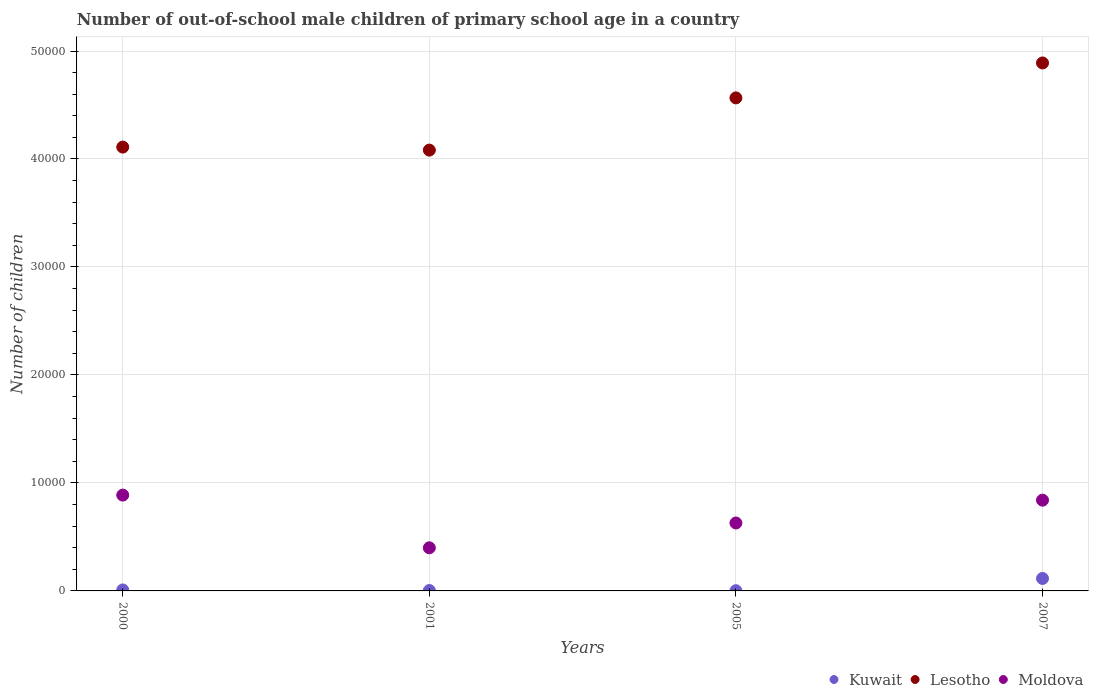How many different coloured dotlines are there?
Offer a very short reply. 3. What is the number of out-of-school male children in Kuwait in 2000?
Offer a terse response. 91. Across all years, what is the maximum number of out-of-school male children in Moldova?
Give a very brief answer. 8873. In which year was the number of out-of-school male children in Moldova maximum?
Ensure brevity in your answer.  2000. In which year was the number of out-of-school male children in Kuwait minimum?
Ensure brevity in your answer.  2005. What is the total number of out-of-school male children in Moldova in the graph?
Your answer should be very brief. 2.76e+04. What is the difference between the number of out-of-school male children in Kuwait in 2000 and that in 2007?
Your answer should be compact. -1064. What is the difference between the number of out-of-school male children in Lesotho in 2001 and the number of out-of-school male children in Moldova in 2005?
Ensure brevity in your answer.  3.45e+04. What is the average number of out-of-school male children in Kuwait per year?
Offer a terse response. 325.5. In the year 2007, what is the difference between the number of out-of-school male children in Lesotho and number of out-of-school male children in Moldova?
Ensure brevity in your answer.  4.05e+04. What is the ratio of the number of out-of-school male children in Lesotho in 2000 to that in 2005?
Offer a terse response. 0.9. What is the difference between the highest and the second highest number of out-of-school male children in Moldova?
Provide a succinct answer. 469. What is the difference between the highest and the lowest number of out-of-school male children in Moldova?
Provide a succinct answer. 4880. In how many years, is the number of out-of-school male children in Kuwait greater than the average number of out-of-school male children in Kuwait taken over all years?
Your response must be concise. 1. Is the sum of the number of out-of-school male children in Lesotho in 2000 and 2001 greater than the maximum number of out-of-school male children in Kuwait across all years?
Provide a succinct answer. Yes. Is it the case that in every year, the sum of the number of out-of-school male children in Moldova and number of out-of-school male children in Lesotho  is greater than the number of out-of-school male children in Kuwait?
Offer a terse response. Yes. Does the number of out-of-school male children in Kuwait monotonically increase over the years?
Provide a succinct answer. No. Is the number of out-of-school male children in Kuwait strictly greater than the number of out-of-school male children in Moldova over the years?
Make the answer very short. No. Is the number of out-of-school male children in Moldova strictly less than the number of out-of-school male children in Lesotho over the years?
Give a very brief answer. Yes. How many dotlines are there?
Your answer should be compact. 3. Are the values on the major ticks of Y-axis written in scientific E-notation?
Give a very brief answer. No. Where does the legend appear in the graph?
Your answer should be compact. Bottom right. How are the legend labels stacked?
Your answer should be very brief. Horizontal. What is the title of the graph?
Make the answer very short. Number of out-of-school male children of primary school age in a country. What is the label or title of the X-axis?
Make the answer very short. Years. What is the label or title of the Y-axis?
Provide a short and direct response. Number of children. What is the Number of children of Kuwait in 2000?
Offer a very short reply. 91. What is the Number of children of Lesotho in 2000?
Offer a very short reply. 4.11e+04. What is the Number of children of Moldova in 2000?
Provide a short and direct response. 8873. What is the Number of children in Kuwait in 2001?
Offer a very short reply. 38. What is the Number of children in Lesotho in 2001?
Offer a terse response. 4.08e+04. What is the Number of children in Moldova in 2001?
Your response must be concise. 3993. What is the Number of children in Kuwait in 2005?
Your answer should be very brief. 18. What is the Number of children in Lesotho in 2005?
Your answer should be compact. 4.57e+04. What is the Number of children in Moldova in 2005?
Your response must be concise. 6291. What is the Number of children of Kuwait in 2007?
Make the answer very short. 1155. What is the Number of children in Lesotho in 2007?
Give a very brief answer. 4.89e+04. What is the Number of children in Moldova in 2007?
Keep it short and to the point. 8404. Across all years, what is the maximum Number of children in Kuwait?
Your response must be concise. 1155. Across all years, what is the maximum Number of children of Lesotho?
Your answer should be compact. 4.89e+04. Across all years, what is the maximum Number of children of Moldova?
Keep it short and to the point. 8873. Across all years, what is the minimum Number of children in Lesotho?
Your response must be concise. 4.08e+04. Across all years, what is the minimum Number of children of Moldova?
Make the answer very short. 3993. What is the total Number of children in Kuwait in the graph?
Ensure brevity in your answer.  1302. What is the total Number of children of Lesotho in the graph?
Ensure brevity in your answer.  1.76e+05. What is the total Number of children in Moldova in the graph?
Your answer should be compact. 2.76e+04. What is the difference between the Number of children of Lesotho in 2000 and that in 2001?
Make the answer very short. 280. What is the difference between the Number of children of Moldova in 2000 and that in 2001?
Ensure brevity in your answer.  4880. What is the difference between the Number of children of Lesotho in 2000 and that in 2005?
Offer a very short reply. -4556. What is the difference between the Number of children of Moldova in 2000 and that in 2005?
Provide a succinct answer. 2582. What is the difference between the Number of children of Kuwait in 2000 and that in 2007?
Offer a terse response. -1064. What is the difference between the Number of children in Lesotho in 2000 and that in 2007?
Your response must be concise. -7790. What is the difference between the Number of children of Moldova in 2000 and that in 2007?
Offer a very short reply. 469. What is the difference between the Number of children in Lesotho in 2001 and that in 2005?
Provide a short and direct response. -4836. What is the difference between the Number of children of Moldova in 2001 and that in 2005?
Offer a very short reply. -2298. What is the difference between the Number of children of Kuwait in 2001 and that in 2007?
Ensure brevity in your answer.  -1117. What is the difference between the Number of children of Lesotho in 2001 and that in 2007?
Offer a very short reply. -8070. What is the difference between the Number of children in Moldova in 2001 and that in 2007?
Your response must be concise. -4411. What is the difference between the Number of children in Kuwait in 2005 and that in 2007?
Offer a very short reply. -1137. What is the difference between the Number of children of Lesotho in 2005 and that in 2007?
Offer a terse response. -3234. What is the difference between the Number of children in Moldova in 2005 and that in 2007?
Your answer should be compact. -2113. What is the difference between the Number of children of Kuwait in 2000 and the Number of children of Lesotho in 2001?
Offer a terse response. -4.07e+04. What is the difference between the Number of children in Kuwait in 2000 and the Number of children in Moldova in 2001?
Provide a short and direct response. -3902. What is the difference between the Number of children in Lesotho in 2000 and the Number of children in Moldova in 2001?
Your response must be concise. 3.71e+04. What is the difference between the Number of children in Kuwait in 2000 and the Number of children in Lesotho in 2005?
Offer a terse response. -4.56e+04. What is the difference between the Number of children in Kuwait in 2000 and the Number of children in Moldova in 2005?
Provide a short and direct response. -6200. What is the difference between the Number of children of Lesotho in 2000 and the Number of children of Moldova in 2005?
Make the answer very short. 3.48e+04. What is the difference between the Number of children of Kuwait in 2000 and the Number of children of Lesotho in 2007?
Offer a very short reply. -4.88e+04. What is the difference between the Number of children of Kuwait in 2000 and the Number of children of Moldova in 2007?
Give a very brief answer. -8313. What is the difference between the Number of children in Lesotho in 2000 and the Number of children in Moldova in 2007?
Ensure brevity in your answer.  3.27e+04. What is the difference between the Number of children in Kuwait in 2001 and the Number of children in Lesotho in 2005?
Your answer should be compact. -4.56e+04. What is the difference between the Number of children in Kuwait in 2001 and the Number of children in Moldova in 2005?
Give a very brief answer. -6253. What is the difference between the Number of children of Lesotho in 2001 and the Number of children of Moldova in 2005?
Give a very brief answer. 3.45e+04. What is the difference between the Number of children of Kuwait in 2001 and the Number of children of Lesotho in 2007?
Provide a short and direct response. -4.89e+04. What is the difference between the Number of children of Kuwait in 2001 and the Number of children of Moldova in 2007?
Your answer should be very brief. -8366. What is the difference between the Number of children in Lesotho in 2001 and the Number of children in Moldova in 2007?
Your answer should be compact. 3.24e+04. What is the difference between the Number of children of Kuwait in 2005 and the Number of children of Lesotho in 2007?
Offer a very short reply. -4.89e+04. What is the difference between the Number of children in Kuwait in 2005 and the Number of children in Moldova in 2007?
Give a very brief answer. -8386. What is the difference between the Number of children of Lesotho in 2005 and the Number of children of Moldova in 2007?
Offer a very short reply. 3.73e+04. What is the average Number of children in Kuwait per year?
Provide a short and direct response. 325.5. What is the average Number of children of Lesotho per year?
Make the answer very short. 4.41e+04. What is the average Number of children of Moldova per year?
Your answer should be compact. 6890.25. In the year 2000, what is the difference between the Number of children of Kuwait and Number of children of Lesotho?
Your answer should be very brief. -4.10e+04. In the year 2000, what is the difference between the Number of children in Kuwait and Number of children in Moldova?
Keep it short and to the point. -8782. In the year 2000, what is the difference between the Number of children in Lesotho and Number of children in Moldova?
Make the answer very short. 3.22e+04. In the year 2001, what is the difference between the Number of children in Kuwait and Number of children in Lesotho?
Offer a terse response. -4.08e+04. In the year 2001, what is the difference between the Number of children in Kuwait and Number of children in Moldova?
Offer a terse response. -3955. In the year 2001, what is the difference between the Number of children in Lesotho and Number of children in Moldova?
Offer a very short reply. 3.68e+04. In the year 2005, what is the difference between the Number of children in Kuwait and Number of children in Lesotho?
Give a very brief answer. -4.56e+04. In the year 2005, what is the difference between the Number of children in Kuwait and Number of children in Moldova?
Make the answer very short. -6273. In the year 2005, what is the difference between the Number of children of Lesotho and Number of children of Moldova?
Offer a very short reply. 3.94e+04. In the year 2007, what is the difference between the Number of children of Kuwait and Number of children of Lesotho?
Your response must be concise. -4.77e+04. In the year 2007, what is the difference between the Number of children of Kuwait and Number of children of Moldova?
Ensure brevity in your answer.  -7249. In the year 2007, what is the difference between the Number of children of Lesotho and Number of children of Moldova?
Ensure brevity in your answer.  4.05e+04. What is the ratio of the Number of children of Kuwait in 2000 to that in 2001?
Your answer should be compact. 2.39. What is the ratio of the Number of children in Moldova in 2000 to that in 2001?
Your answer should be very brief. 2.22. What is the ratio of the Number of children of Kuwait in 2000 to that in 2005?
Keep it short and to the point. 5.06. What is the ratio of the Number of children in Lesotho in 2000 to that in 2005?
Provide a short and direct response. 0.9. What is the ratio of the Number of children of Moldova in 2000 to that in 2005?
Provide a succinct answer. 1.41. What is the ratio of the Number of children of Kuwait in 2000 to that in 2007?
Give a very brief answer. 0.08. What is the ratio of the Number of children of Lesotho in 2000 to that in 2007?
Your answer should be very brief. 0.84. What is the ratio of the Number of children of Moldova in 2000 to that in 2007?
Your answer should be compact. 1.06. What is the ratio of the Number of children in Kuwait in 2001 to that in 2005?
Provide a short and direct response. 2.11. What is the ratio of the Number of children of Lesotho in 2001 to that in 2005?
Offer a very short reply. 0.89. What is the ratio of the Number of children in Moldova in 2001 to that in 2005?
Give a very brief answer. 0.63. What is the ratio of the Number of children of Kuwait in 2001 to that in 2007?
Provide a succinct answer. 0.03. What is the ratio of the Number of children in Lesotho in 2001 to that in 2007?
Offer a very short reply. 0.83. What is the ratio of the Number of children in Moldova in 2001 to that in 2007?
Make the answer very short. 0.48. What is the ratio of the Number of children in Kuwait in 2005 to that in 2007?
Keep it short and to the point. 0.02. What is the ratio of the Number of children of Lesotho in 2005 to that in 2007?
Make the answer very short. 0.93. What is the ratio of the Number of children of Moldova in 2005 to that in 2007?
Your response must be concise. 0.75. What is the difference between the highest and the second highest Number of children of Kuwait?
Give a very brief answer. 1064. What is the difference between the highest and the second highest Number of children of Lesotho?
Make the answer very short. 3234. What is the difference between the highest and the second highest Number of children of Moldova?
Provide a succinct answer. 469. What is the difference between the highest and the lowest Number of children in Kuwait?
Ensure brevity in your answer.  1137. What is the difference between the highest and the lowest Number of children of Lesotho?
Make the answer very short. 8070. What is the difference between the highest and the lowest Number of children in Moldova?
Your answer should be compact. 4880. 